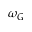Convert formula to latex. <formula><loc_0><loc_0><loc_500><loc_500>\omega _ { G }</formula> 